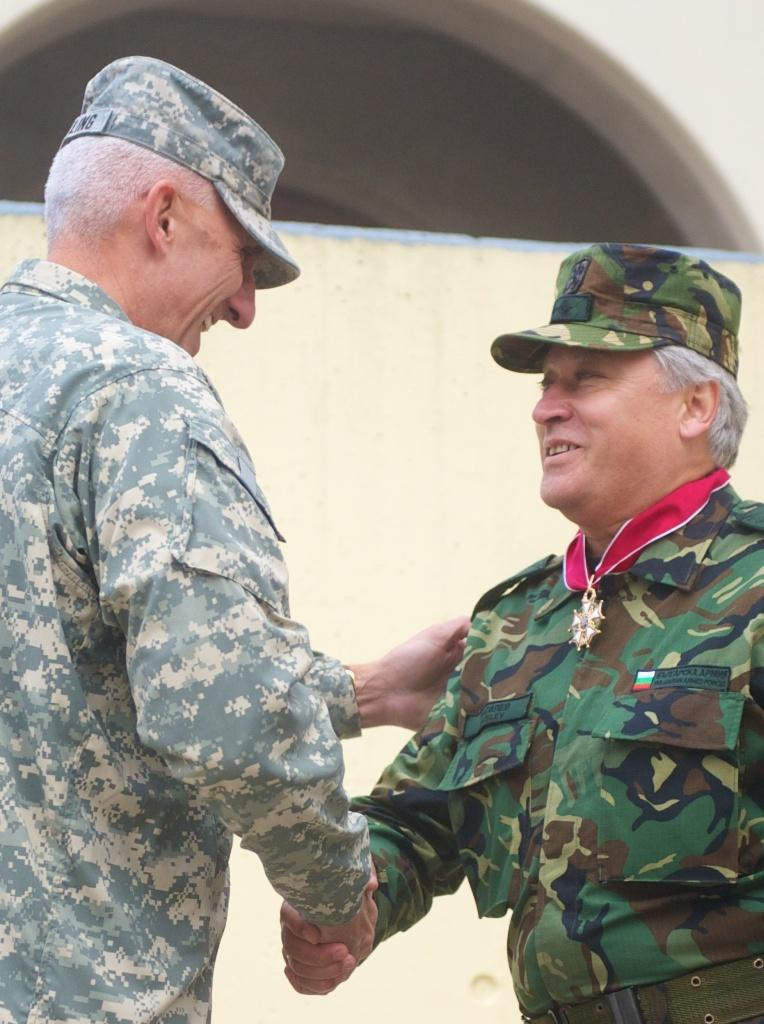How many people are in the image? There are two people in the image. What are the two people wearing? The two people are wearing army dresses and hats. What can be seen in the background of the image? There is a building in the background of the image. Where is the rake being used in the image? There is no rake present in the image. Can you see any cobwebs in the image? There is no mention of cobwebs in the image, so we cannot determine if they are present or not. 